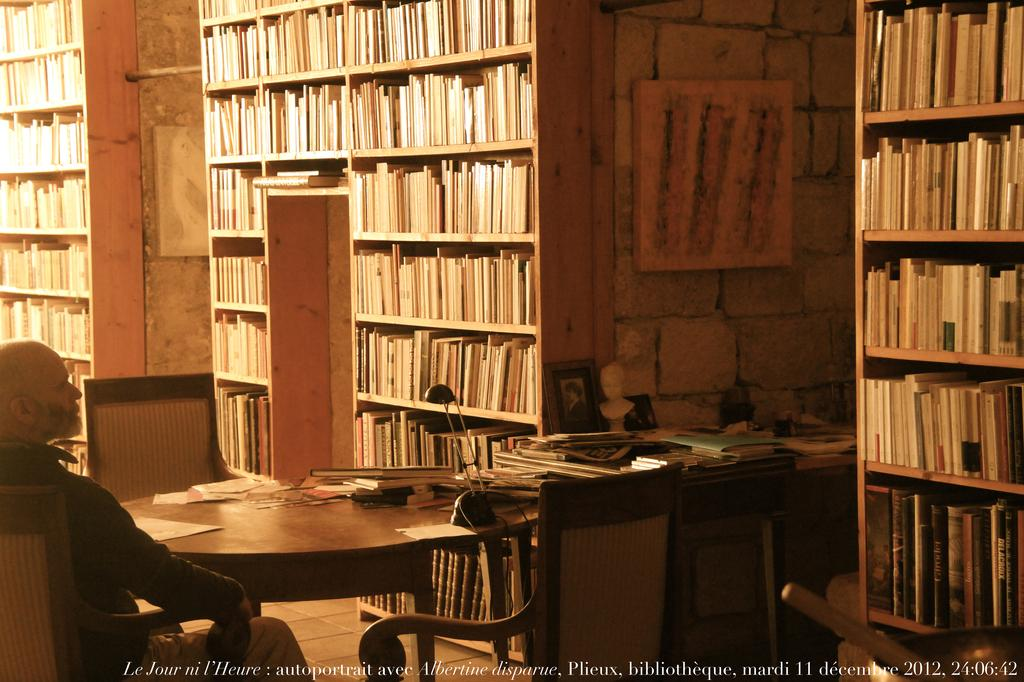<image>
Share a concise interpretation of the image provided. A middle aged man is sitting at a round table, in a library on December 11, 2012. 